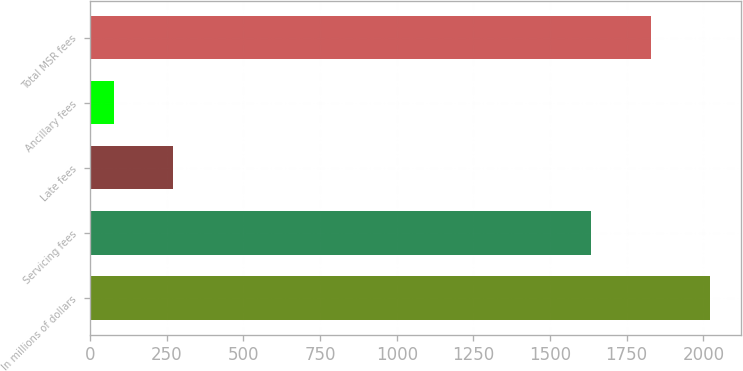Convert chart to OTSL. <chart><loc_0><loc_0><loc_500><loc_500><bar_chart><fcel>In millions of dollars<fcel>Servicing fees<fcel>Late fees<fcel>Ancillary fees<fcel>Total MSR fees<nl><fcel>2021.4<fcel>1635<fcel>270.2<fcel>77<fcel>1828.2<nl></chart> 